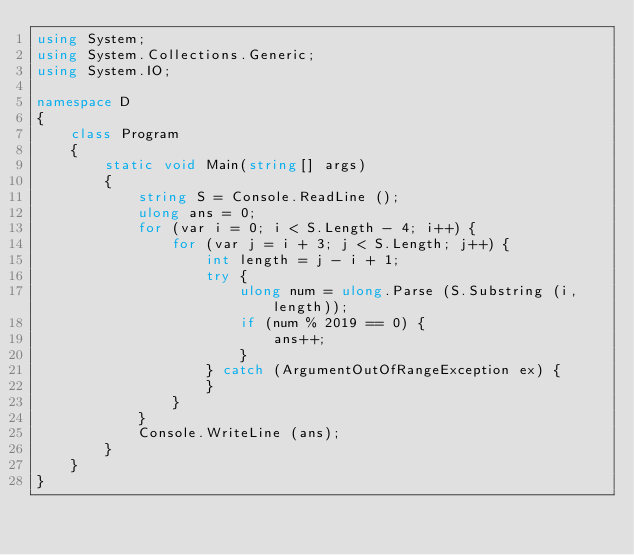Convert code to text. <code><loc_0><loc_0><loc_500><loc_500><_C#_>using System;
using System.Collections.Generic;
using System.IO;

namespace D
{
    class Program
    {
        static void Main(string[] args)
        {
            string S = Console.ReadLine ();
            ulong ans = 0;
            for (var i = 0; i < S.Length - 4; i++) {
                for (var j = i + 3; j < S.Length; j++) {
                    int length = j - i + 1;
                    try {
                        ulong num = ulong.Parse (S.Substring (i, length));
                        if (num % 2019 == 0) {
                            ans++;
                        }
                    } catch (ArgumentOutOfRangeException ex) {
                    }
                }
            }
            Console.WriteLine (ans);
        }
    }
}
</code> 